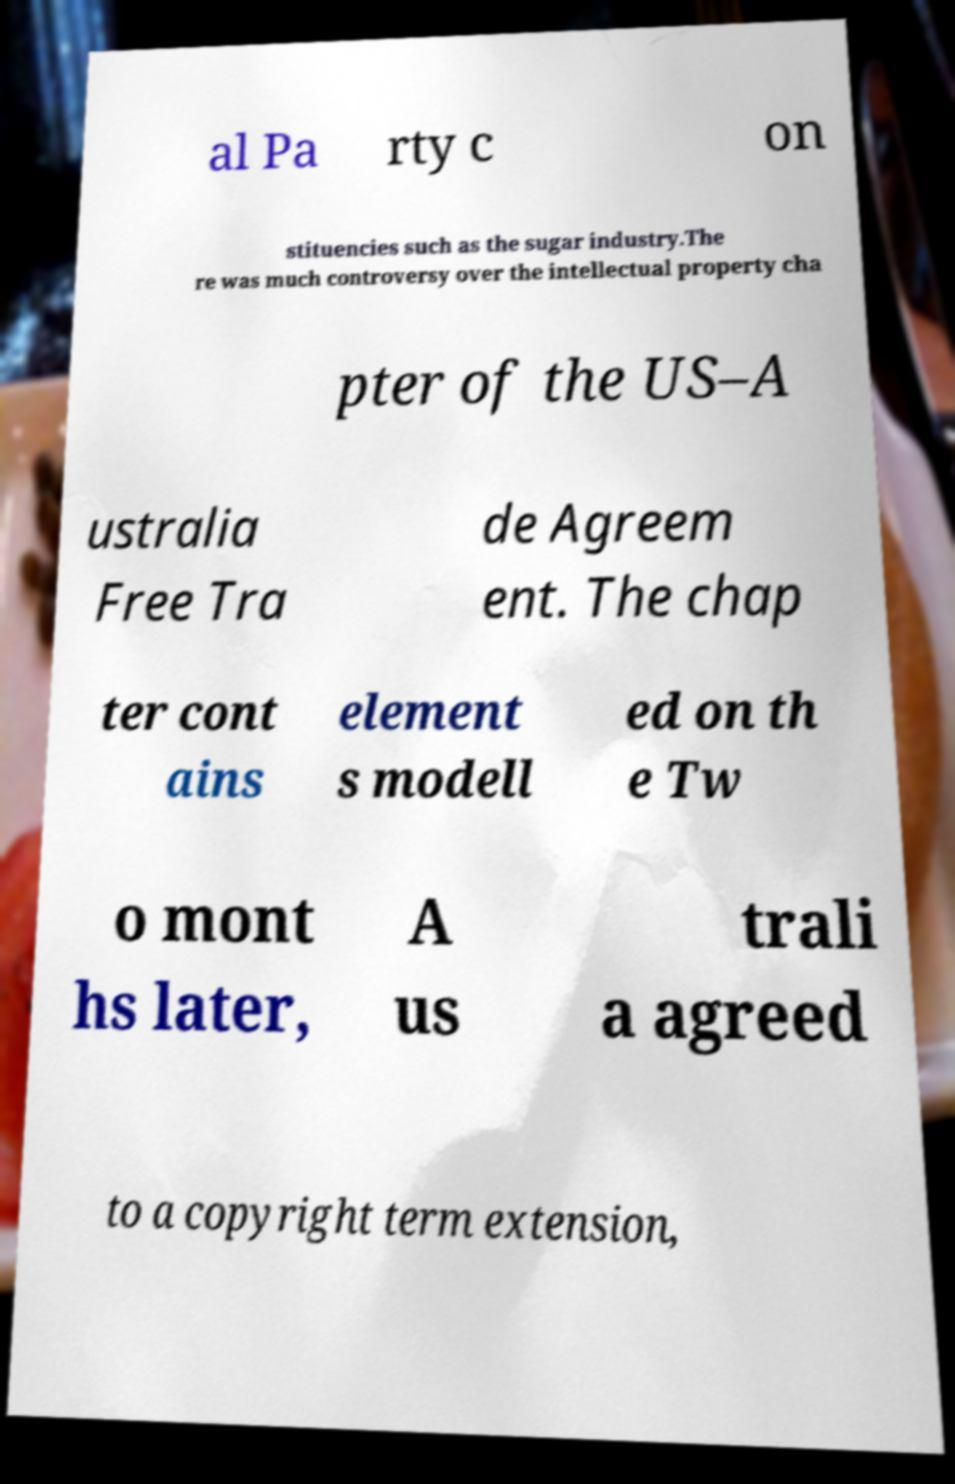There's text embedded in this image that I need extracted. Can you transcribe it verbatim? al Pa rty c on stituencies such as the sugar industry.The re was much controversy over the intellectual property cha pter of the US–A ustralia Free Tra de Agreem ent. The chap ter cont ains element s modell ed on th e Tw o mont hs later, A us trali a agreed to a copyright term extension, 